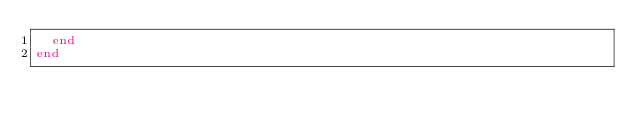Convert code to text. <code><loc_0><loc_0><loc_500><loc_500><_Ruby_>  end
end
</code> 